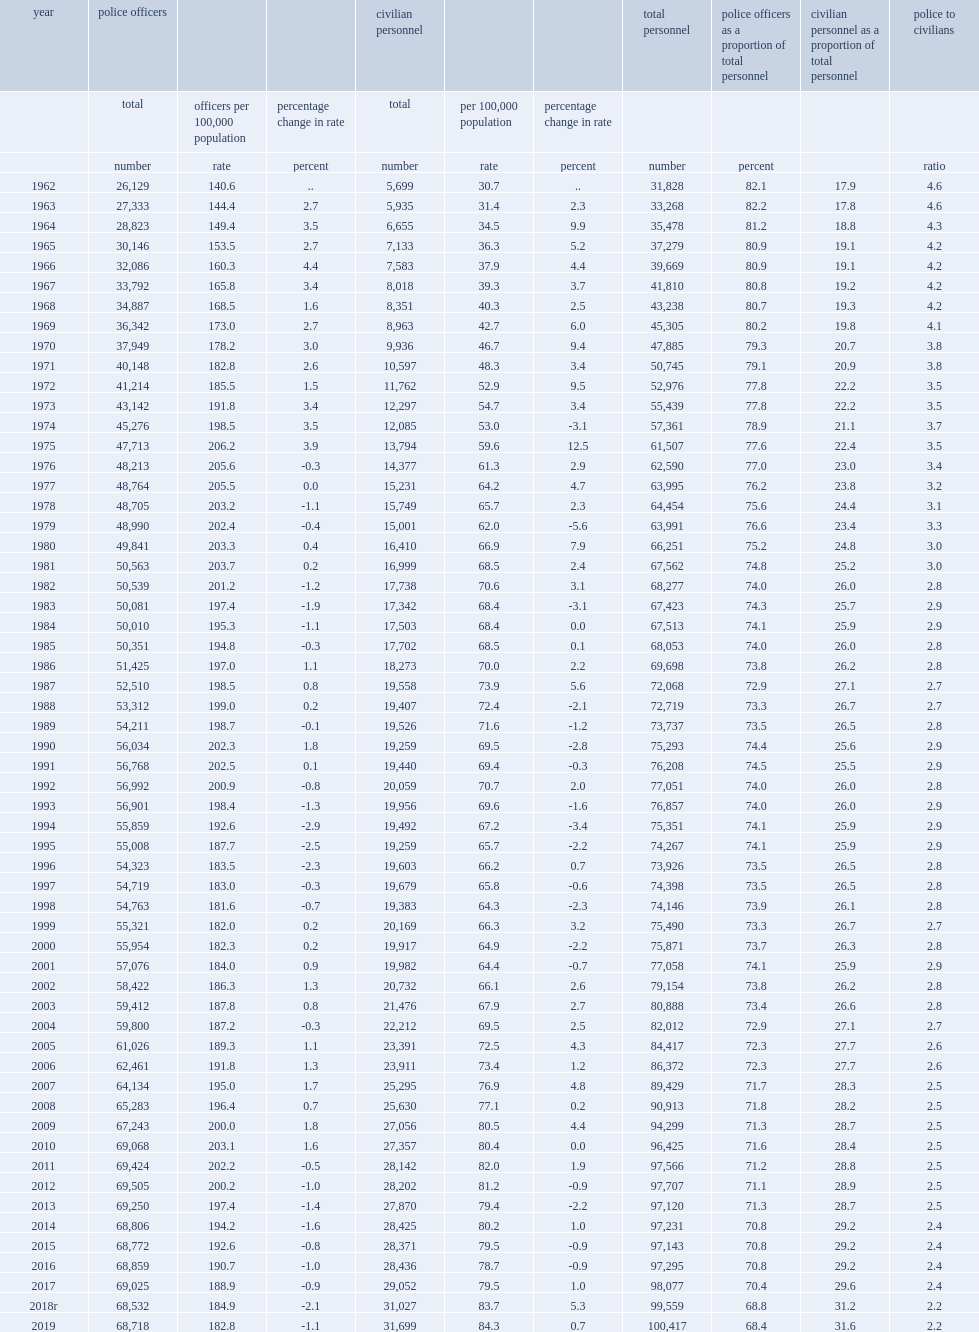Which year marks the lowest police strength rate since 2001? 2019.0. How many police officers were there in canada in 2019? 68718.0. How many more police officers were there in canada in 2019 than in 2018? 186. How many full-time individuals were employed by police services in 2019? 31699.0. How many more employees were employed by police services in 2019 than 2018? 672. What percentage of total police service personnel were employees who were not sworn officers in 1962? 17.9. What percentage of total police service personnel were employees who were not sworn officers in 2019? 31.6. Which year had a higher number of employees who were not sworn officers, 1962 or 2019? 2019.0. 